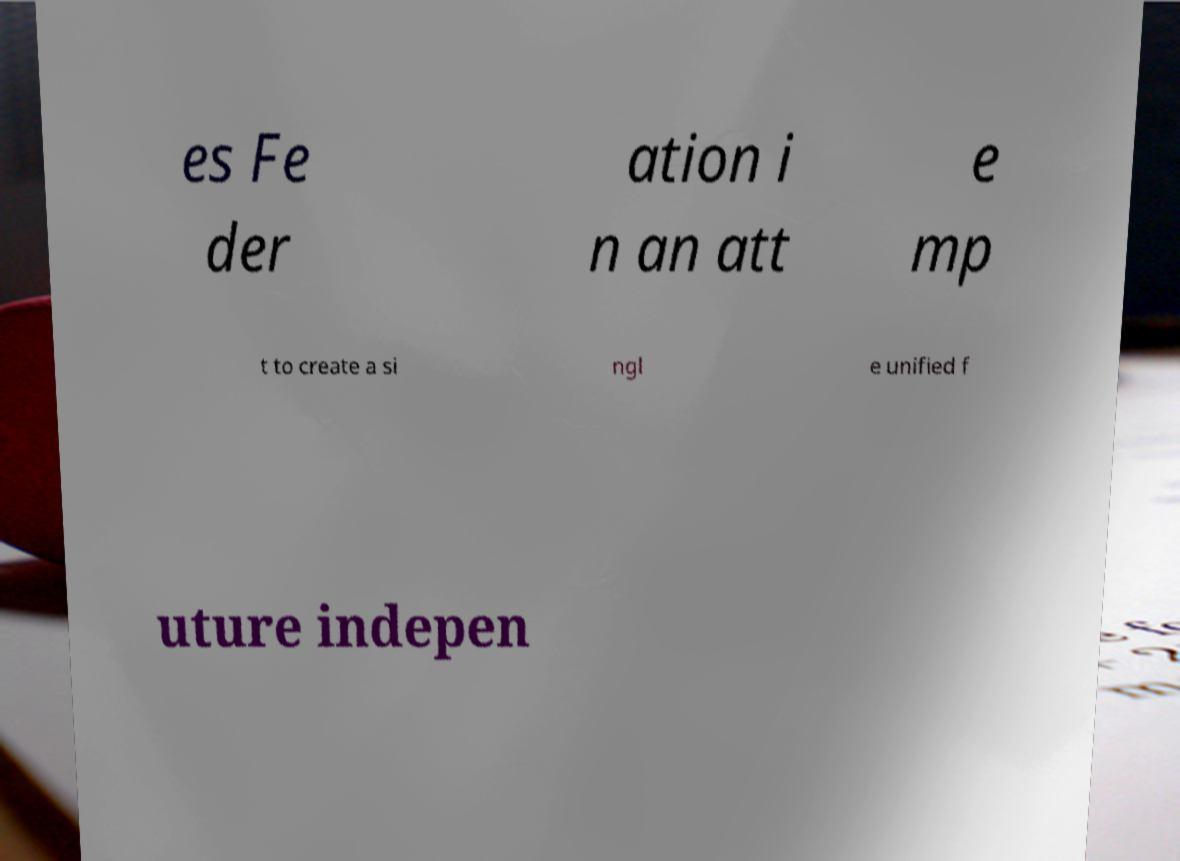Please read and relay the text visible in this image. What does it say? es Fe der ation i n an att e mp t to create a si ngl e unified f uture indepen 